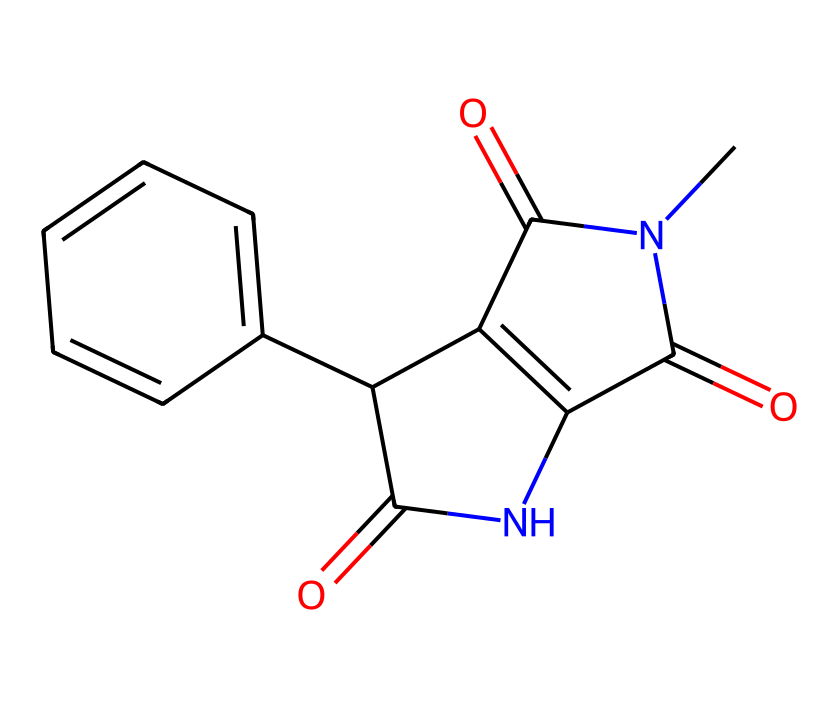How many nitrogen atoms are present in this molecule? By examining the SMILES representation, we can identify the nitrogen atoms represented by the letter "N". Counting the occurrences, we see there are two "N" letters in the structure.
Answer: two What is the molecular formula of thalidomide? To derive the molecular formula, we identify all the atoms in the structure from the SMILES. It contains 13 carbons (C), 10 hydrogens (H), 2 nitrogens (N), and 4 oxygens (O), thus giving us the formula C13H10N2O4.
Answer: C13H10N2O4 Which functional groups are present in the structure? The identification of functional groups involves recognizing key elements in the structure. This molecule contains carbonyl groups (=O), amide (C=O and -N), and aromatic rings. Each of these indicates specific functional properties.
Answer: carbonyl, amide, aromatic How many stereocenters are present in the thalidomide structure? A stereocenter is typically a carbon atom attached to four different substituents. By examining the structure, we can identify the carbon atoms and determine that there are two in this molecule that meet this criterion.
Answer: two What is the primary reason thalidomide has stereogenic centers? Stereogenic centers arise when a carbon atom is bonded to four distinct substituents, which imposes chirality. In thalidomide's structure, the presence of functional groups and overall structural symmetry contributes to the stereogenic characteristics.
Answer: chirality What are the biological implications of the two enantiomers of thalidomide? The two enantiomers of thalidomide differ in biological activity; one is therapeutic while the other is teratogenic, leading to severe birth defects. This differential effect highlights the importance of stereochemistry in drug efficacy and safety.
Answer: therapeutic, teratogenic 